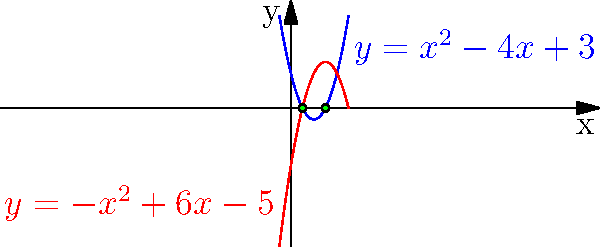In our ancestral courtyard, two curved paths intersect, symbolizing the meeting of different legal traditions. These paths are represented by the equations $y = x^2 - 4x + 3$ and $y = -x^2 + 6x - 5$. At which points do these paths cross, signifying the convergence of our legal wisdom? To find the intersection points of the two parabolas, we need to solve the system of equations:

$$y = x^2 - 4x + 3$$
$$y = -x^2 + 6x - 5$$

Step 1: Set the equations equal to each other since they intersect at points where y-values are the same.
$$x^2 - 4x + 3 = -x^2 + 6x - 5$$

Step 2: Rearrange the equation to standard form.
$$2x^2 - 10x + 8 = 0$$

Step 3: Divide all terms by 2 to simplify.
$$x^2 - 5x + 4 = 0$$

Step 4: Use the quadratic formula $x = \frac{-b \pm \sqrt{b^2 - 4ac}}{2a}$ where $a=1$, $b=-5$, and $c=4$.

$$x = \frac{5 \pm \sqrt{25 - 16}}{2} = \frac{5 \pm 3}{2}$$

Step 5: Solve for x.
$$x_1 = \frac{5 + 3}{2} = 4$$
$$x_2 = \frac{5 - 3}{2} = 1$$

Step 6: Find the corresponding y-values by substituting x values into either original equation.
For $x = 1$: $y = 1^2 - 4(1) + 3 = 0$
For $x = 3$: $y = 3^2 - 4(3) + 3 = 0$

Therefore, the intersection points are (1, 0) and (3, 0).
Answer: (1, 0) and (3, 0) 